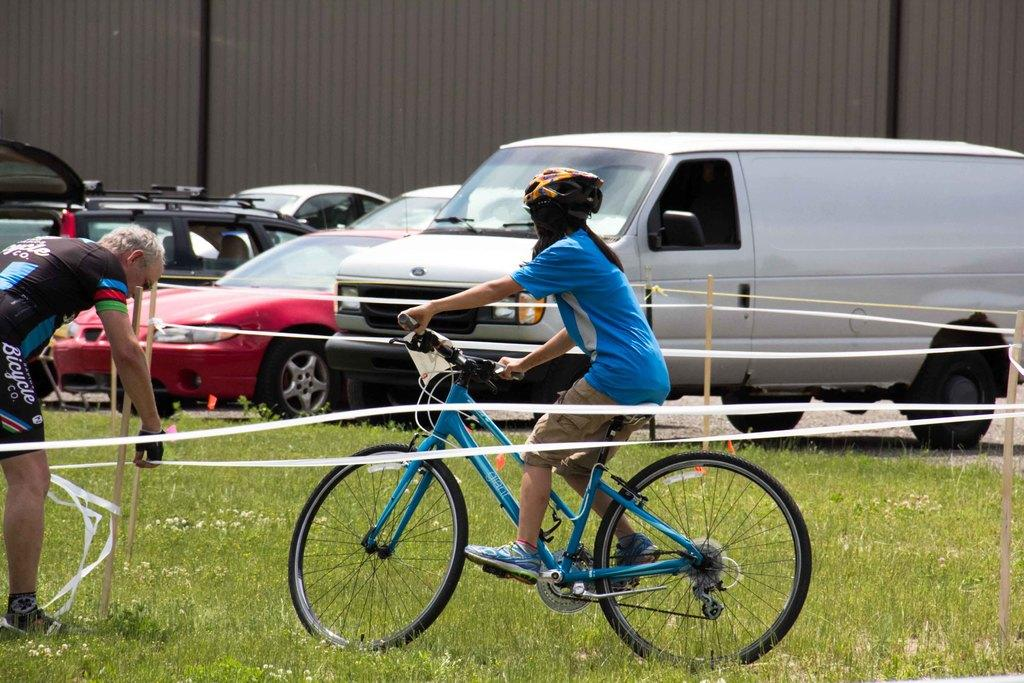What is the child doing in the image? The child is on a cycle in the image. What is the man doing in the image? The man is on the grass in the image. How many cars can be seen in the background of the image? There are 5 cars visible in the background of the image. What is present in the background of the image? There is a wall in the background of the image. What type of notebook is the child using to write on the cycle? There is no notebook present in the image, and the child is not writing on the cycle. 